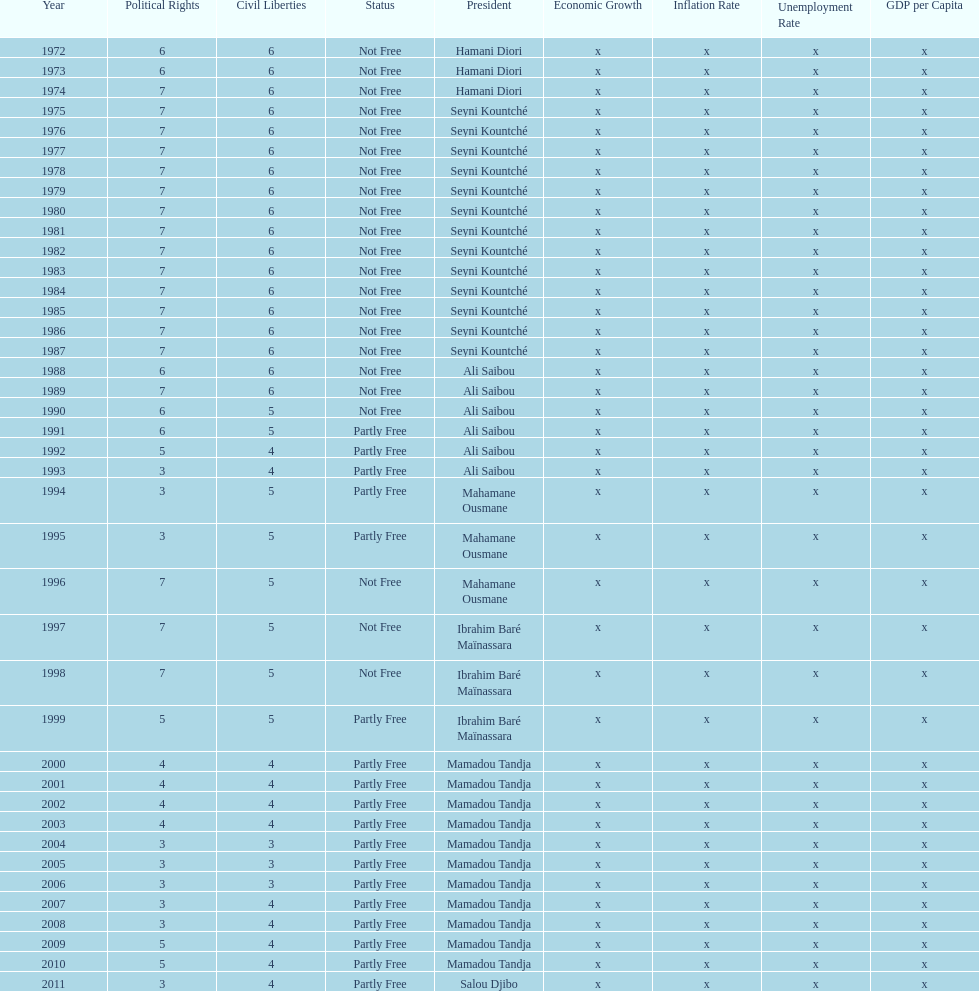How many times was the political rights listed as seven? 18. 